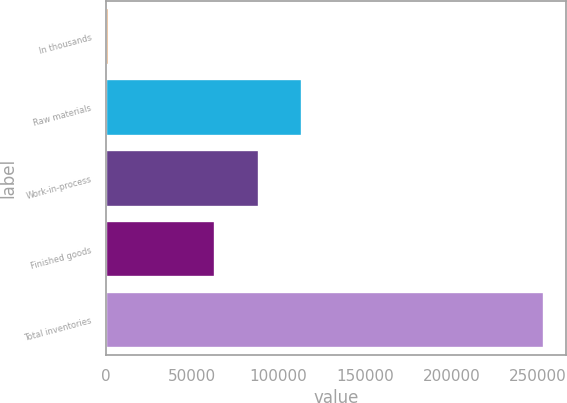<chart> <loc_0><loc_0><loc_500><loc_500><bar_chart><fcel>In thousands<fcel>Raw materials<fcel>Work-in-process<fcel>Finished goods<fcel>Total inventories<nl><fcel>2010<fcel>113765<fcel>88617.1<fcel>63469<fcel>253491<nl></chart> 